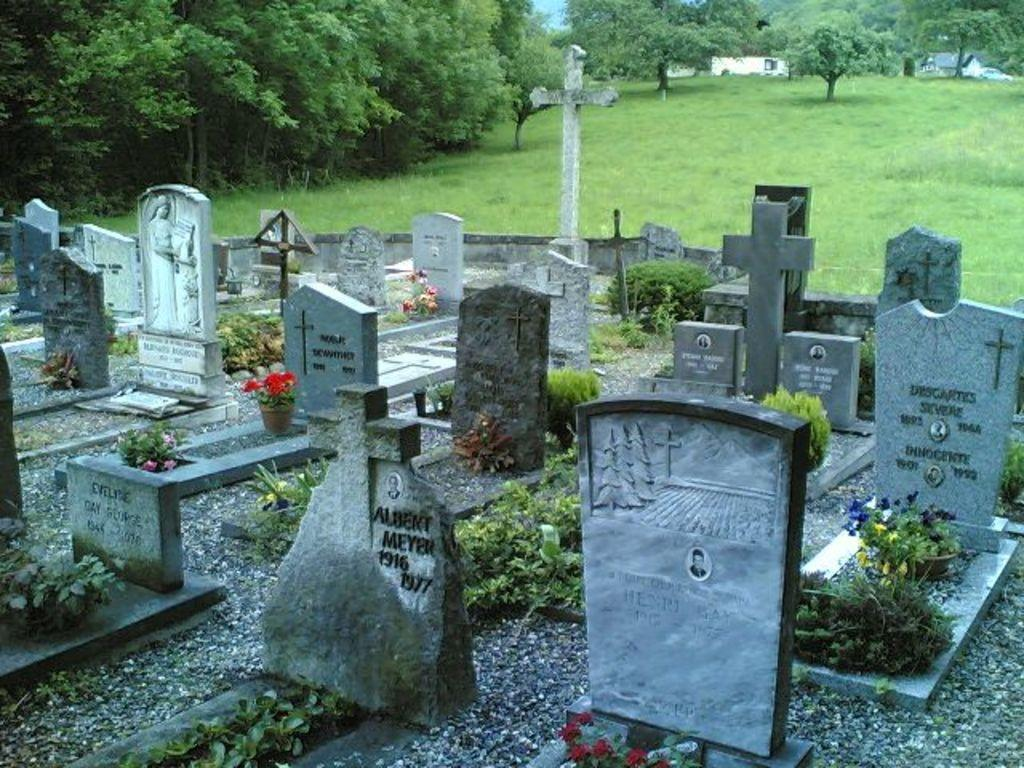What is the main subject in the foreground of the image? There is a graveyard in the foreground of the image. What is the ground covered with? The ground is covered with grass. Where are the trees located in the image? There is a group of trees in the top left-hand corner of the image. What type of plantation can be seen in the image? There is no plantation present in the image; it features a graveyard and trees. How are the people in the image transporting themselves around the graveyard? There are no people visible in the image, so it is impossible to determine how they might be transporting themselves. 